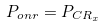Convert formula to latex. <formula><loc_0><loc_0><loc_500><loc_500>P _ { o n r } = P _ { C R _ { x } }</formula> 